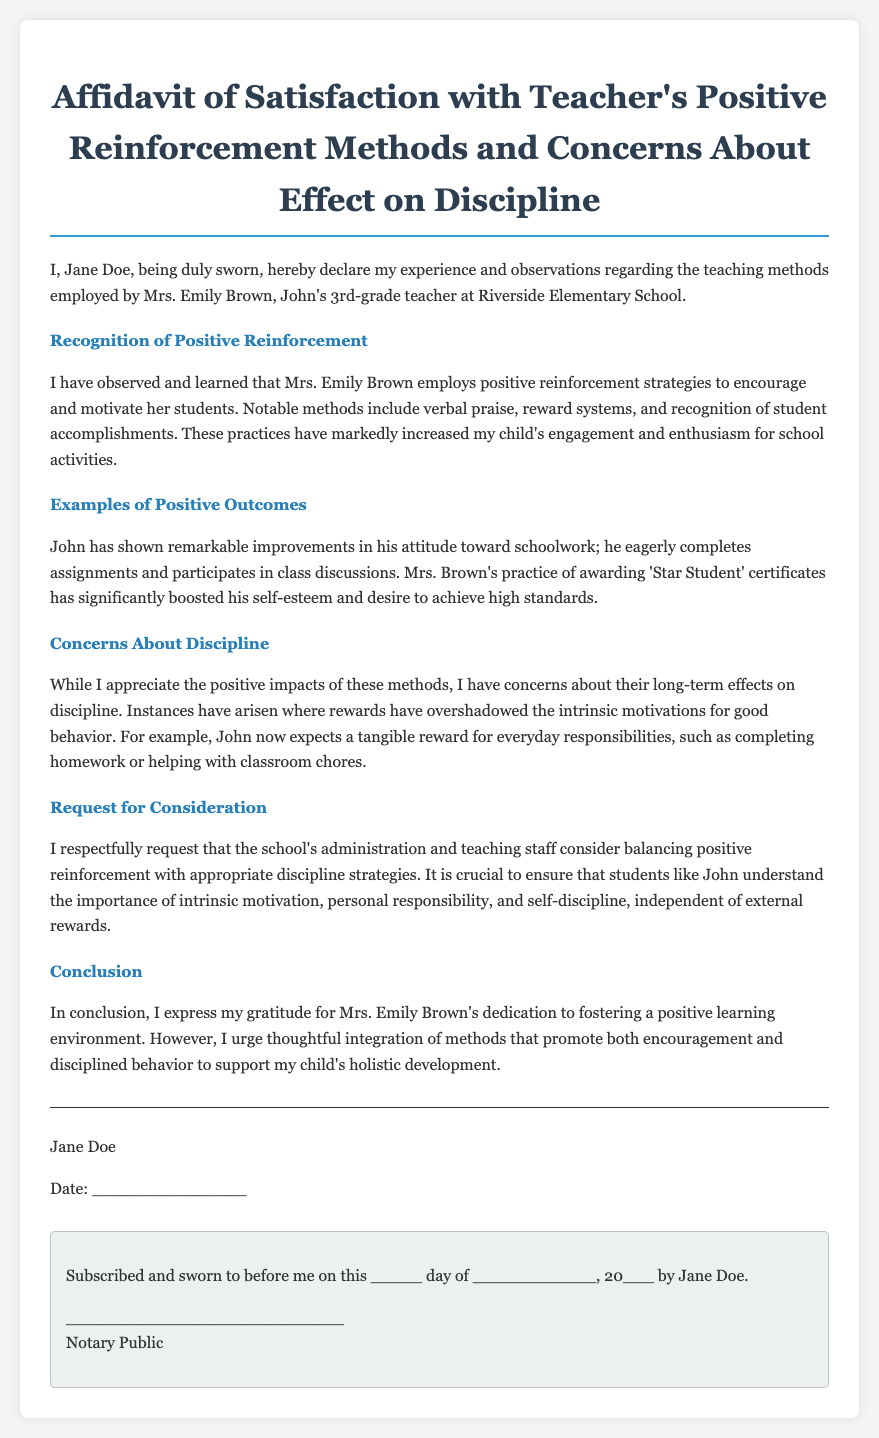What is the name of the teacher mentioned in the affidavit? The teacher referred to in the affidavit is Mrs. Emily Brown.
Answer: Mrs. Emily Brown What grade does John's teacher teach? The document states that John is in 3rd grade.
Answer: 3rd grade What is one method used by Mrs. Brown for positive reinforcement? The affidavit mentions that verbal praise is one of the methods.
Answer: Verbal praise What item does John receive that boosts his self-esteem? John receives 'Star Student' certificates which increase his self-esteem.
Answer: 'Star Student' certificates What is the main concern expressed by the parent? The parent is concerned about the long-term effects of positive reinforcement on discipline.
Answer: Long-term effects on discipline What is requested by the parent regarding teaching methods? The parent requests a balance between positive reinforcement and appropriate discipline strategies.
Answer: Balance What positive outcome is noted for John regarding his attitude? John has shown remarkable improvements in his attitude toward schoolwork.
Answer: Remarkable improvements in attitude Who is the affiant of the document? The affiant, or person making the affidavit, is Jane Doe.
Answer: Jane Doe On what date should the affidavit be signed? The signing date is indicated as a placeholder in the document; it is not specified.
Answer: _______________ What is the purpose of this affidavit? The purpose of the affidavit is to express satisfaction with teaching methods and concerns about discipline.
Answer: Satisfaction with teaching methods and concerns about discipline 